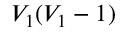<formula> <loc_0><loc_0><loc_500><loc_500>V _ { 1 } ( V _ { 1 } - 1 )</formula> 